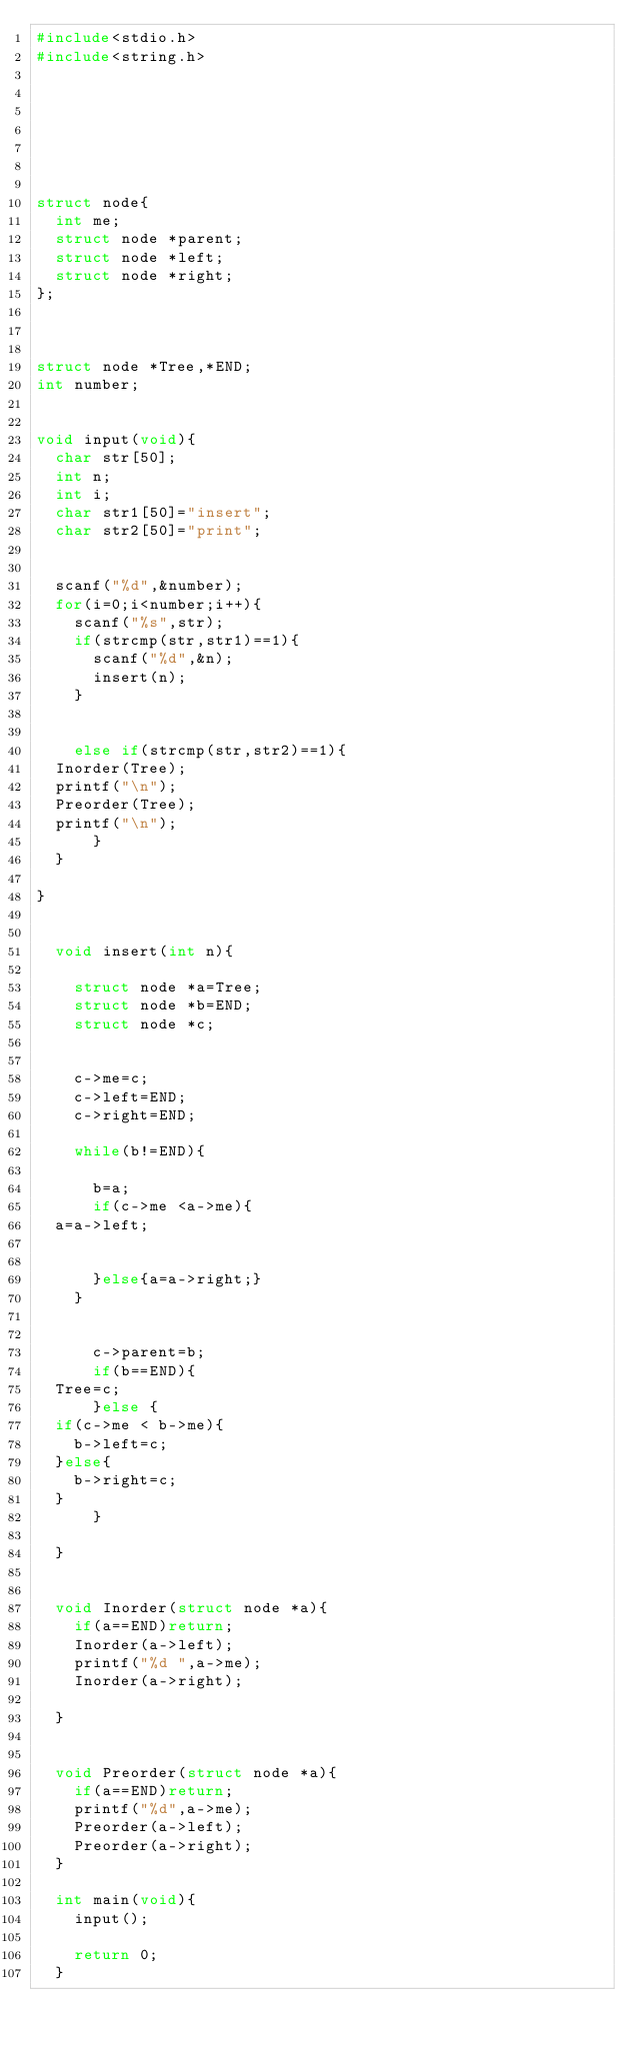Convert code to text. <code><loc_0><loc_0><loc_500><loc_500><_C_>#include<stdio.h>
#include<string.h>







struct node{
  int me;
  struct node *parent;
  struct node *left;
  struct node *right;
};



struct node *Tree,*END;
int number;


void input(void){
  char str[50];
  int n;
  int i;
  char str1[50]="insert";
  char str2[50]="print";

  
  scanf("%d",&number);
  for(i=0;i<number;i++){
    scanf("%s",str);
    if(strcmp(str,str1)==1){
      scanf("%d",&n);
      insert(n);
    }


    else if(strcmp(str,str2)==1){
	Inorder(Tree);
	printf("\n");
	Preorder(Tree);
	printf("\n");
      }
  }

}


  void insert(int n){

    struct node *a=Tree;
    struct node *b=END;
    struct node *c;


    c->me=c;
    c->left=END;
    c->right=END;

    while(b!=END){

      b=a;
      if(c->me <a->me){
	a=a->left;
	

      }else{a=a->right;}
    }

    
      c->parent=b;
      if(b==END){
	Tree=c;
      }else {
	if(c->me < b->me){
	  b->left=c;
	}else{
	  b->right=c;
	}
      }
   
  }


  void Inorder(struct node *a){
    if(a==END)return;
    Inorder(a->left);
    printf("%d ",a->me);
    Inorder(a->right);
    
  }


  void Preorder(struct node *a){
    if(a==END)return;
    printf("%d",a->me);
    Preorder(a->left);
    Preorder(a->right);
  }

  int main(void){
    input();

    return 0;
  }

</code> 